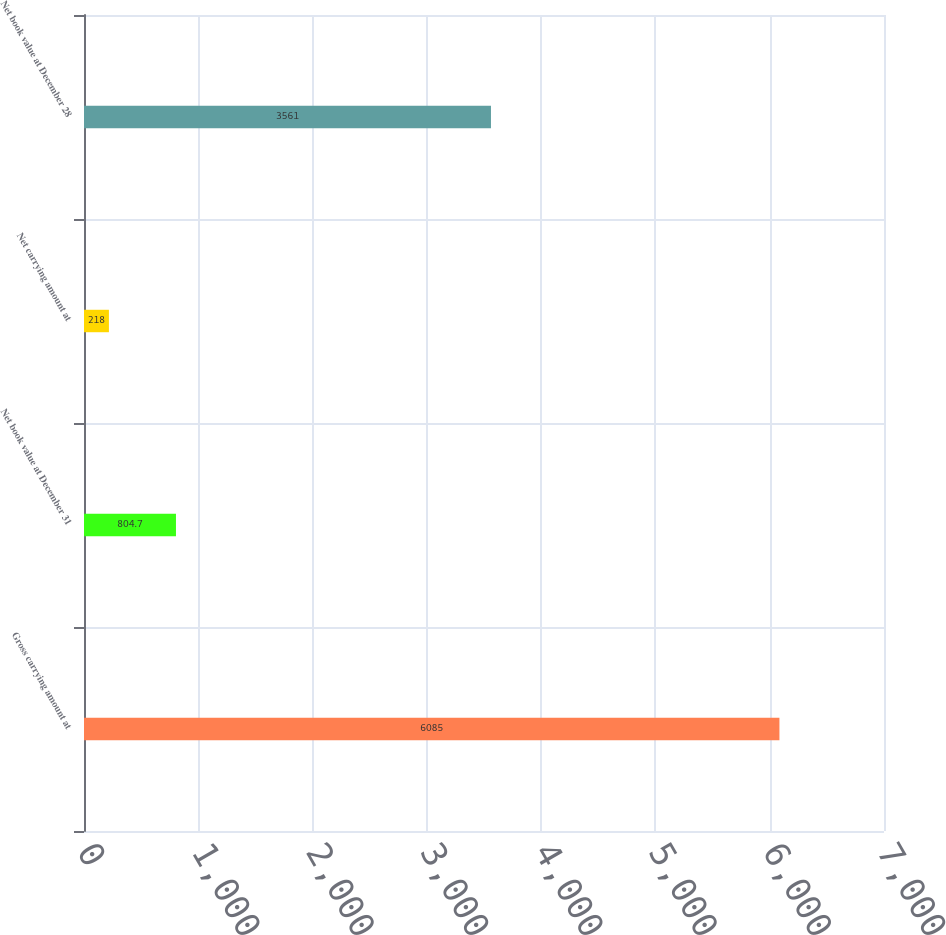Convert chart to OTSL. <chart><loc_0><loc_0><loc_500><loc_500><bar_chart><fcel>Gross carrying amount at<fcel>Net book value at December 31<fcel>Net carrying amount at<fcel>Net book value at December 28<nl><fcel>6085<fcel>804.7<fcel>218<fcel>3561<nl></chart> 